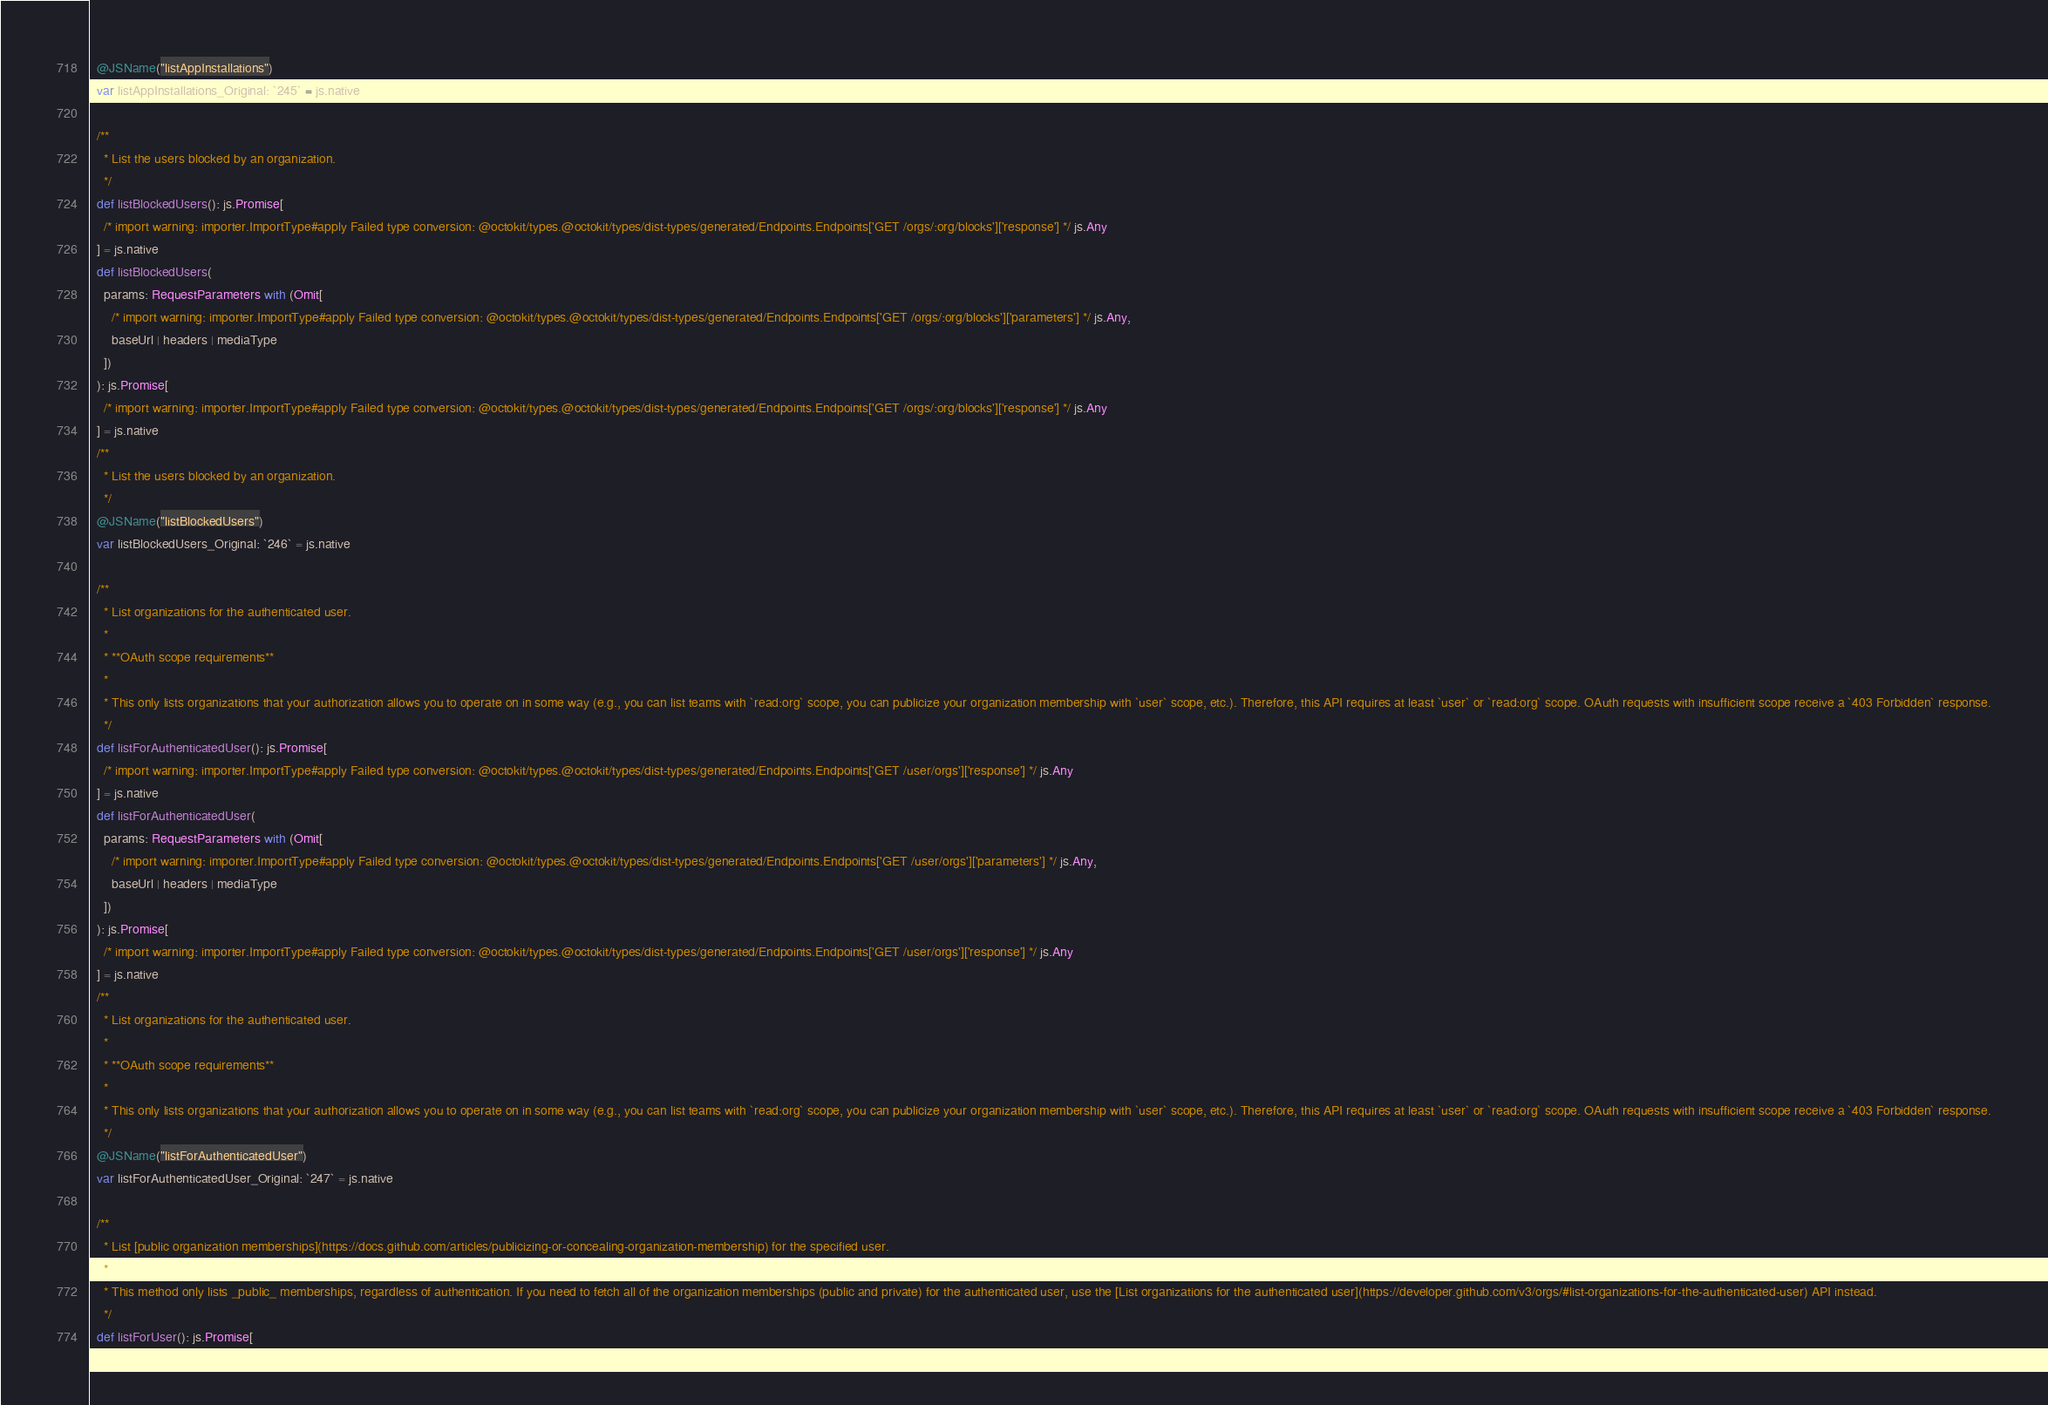<code> <loc_0><loc_0><loc_500><loc_500><_Scala_>  @JSName("listAppInstallations")
  var listAppInstallations_Original: `245` = js.native
  
  /**
    * List the users blocked by an organization.
    */
  def listBlockedUsers(): js.Promise[
    /* import warning: importer.ImportType#apply Failed type conversion: @octokit/types.@octokit/types/dist-types/generated/Endpoints.Endpoints['GET /orgs/:org/blocks']['response'] */ js.Any
  ] = js.native
  def listBlockedUsers(
    params: RequestParameters with (Omit[
      /* import warning: importer.ImportType#apply Failed type conversion: @octokit/types.@octokit/types/dist-types/generated/Endpoints.Endpoints['GET /orgs/:org/blocks']['parameters'] */ js.Any, 
      baseUrl | headers | mediaType
    ])
  ): js.Promise[
    /* import warning: importer.ImportType#apply Failed type conversion: @octokit/types.@octokit/types/dist-types/generated/Endpoints.Endpoints['GET /orgs/:org/blocks']['response'] */ js.Any
  ] = js.native
  /**
    * List the users blocked by an organization.
    */
  @JSName("listBlockedUsers")
  var listBlockedUsers_Original: `246` = js.native
  
  /**
    * List organizations for the authenticated user.
    *
    * **OAuth scope requirements**
    *
    * This only lists organizations that your authorization allows you to operate on in some way (e.g., you can list teams with `read:org` scope, you can publicize your organization membership with `user` scope, etc.). Therefore, this API requires at least `user` or `read:org` scope. OAuth requests with insufficient scope receive a `403 Forbidden` response.
    */
  def listForAuthenticatedUser(): js.Promise[
    /* import warning: importer.ImportType#apply Failed type conversion: @octokit/types.@octokit/types/dist-types/generated/Endpoints.Endpoints['GET /user/orgs']['response'] */ js.Any
  ] = js.native
  def listForAuthenticatedUser(
    params: RequestParameters with (Omit[
      /* import warning: importer.ImportType#apply Failed type conversion: @octokit/types.@octokit/types/dist-types/generated/Endpoints.Endpoints['GET /user/orgs']['parameters'] */ js.Any, 
      baseUrl | headers | mediaType
    ])
  ): js.Promise[
    /* import warning: importer.ImportType#apply Failed type conversion: @octokit/types.@octokit/types/dist-types/generated/Endpoints.Endpoints['GET /user/orgs']['response'] */ js.Any
  ] = js.native
  /**
    * List organizations for the authenticated user.
    *
    * **OAuth scope requirements**
    *
    * This only lists organizations that your authorization allows you to operate on in some way (e.g., you can list teams with `read:org` scope, you can publicize your organization membership with `user` scope, etc.). Therefore, this API requires at least `user` or `read:org` scope. OAuth requests with insufficient scope receive a `403 Forbidden` response.
    */
  @JSName("listForAuthenticatedUser")
  var listForAuthenticatedUser_Original: `247` = js.native
  
  /**
    * List [public organization memberships](https://docs.github.com/articles/publicizing-or-concealing-organization-membership) for the specified user.
    *
    * This method only lists _public_ memberships, regardless of authentication. If you need to fetch all of the organization memberships (public and private) for the authenticated user, use the [List organizations for the authenticated user](https://developer.github.com/v3/orgs/#list-organizations-for-the-authenticated-user) API instead.
    */
  def listForUser(): js.Promise[</code> 